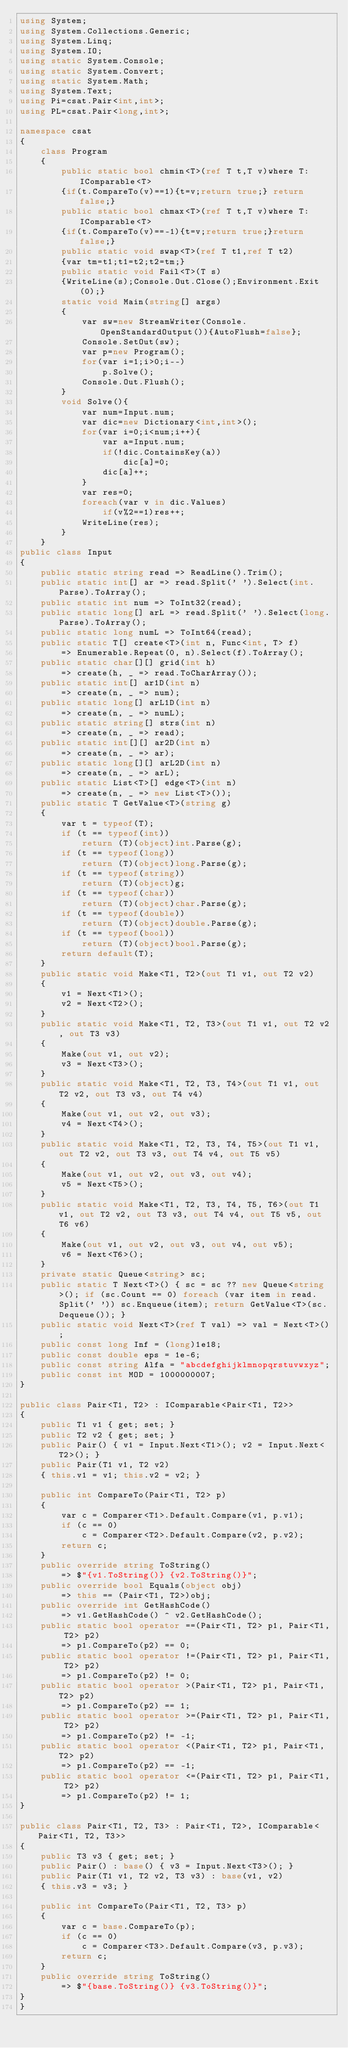<code> <loc_0><loc_0><loc_500><loc_500><_C#_>using System;
using System.Collections.Generic;
using System.Linq;
using System.IO;
using static System.Console;
using static System.Convert;
using static System.Math;
using System.Text;
using Pi=csat.Pair<int,int>;
using PL=csat.Pair<long,int>;

namespace csat
{
    class Program
    {
        public static bool chmin<T>(ref T t,T v)where T:IComparable<T>
        {if(t.CompareTo(v)==1){t=v;return true;} return false;}
        public static bool chmax<T>(ref T t,T v)where T:IComparable<T>
        {if(t.CompareTo(v)==-1){t=v;return true;}return false;}
        public static void swap<T>(ref T t1,ref T t2)
        {var tm=t1;t1=t2;t2=tm;}
        public static void Fail<T>(T s)
        {WriteLine(s);Console.Out.Close();Environment.Exit(0);}
        static void Main(string[] args)
        {
            var sw=new StreamWriter(Console.OpenStandardOutput()){AutoFlush=false};
            Console.SetOut(sw);
            var p=new Program();
            for(var i=1;i>0;i--)
                p.Solve();
            Console.Out.Flush();
        }
        void Solve(){
            var num=Input.num;
            var dic=new Dictionary<int,int>();
            for(var i=0;i<num;i++){
                var a=Input.num;
                if(!dic.ContainsKey(a))
                    dic[a]=0;
                dic[a]++;
            }
            var res=0;
            foreach(var v in dic.Values)
                if(v%2==1)res++;
            WriteLine(res);
        }
    }
public class Input
{
    public static string read => ReadLine().Trim();
    public static int[] ar => read.Split(' ').Select(int.Parse).ToArray();
    public static int num => ToInt32(read);
    public static long[] arL => read.Split(' ').Select(long.Parse).ToArray();
    public static long numL => ToInt64(read);
    public static T[] create<T>(int n, Func<int, T> f)
        => Enumerable.Repeat(0, n).Select(f).ToArray();
    public static char[][] grid(int h)
        => create(h, _ => read.ToCharArray());
    public static int[] ar1D(int n)
        => create(n, _ => num);
    public static long[] arL1D(int n)
        => create(n, _ => numL);
    public static string[] strs(int n)
        => create(n, _ => read);
    public static int[][] ar2D(int n)
        => create(n, _ => ar);
    public static long[][] arL2D(int n)
        => create(n, _ => arL);
    public static List<T>[] edge<T>(int n)
        => create(n, _ => new List<T>());
    public static T GetValue<T>(string g)
    {
        var t = typeof(T);
        if (t == typeof(int))
            return (T)(object)int.Parse(g);
        if (t == typeof(long))
            return (T)(object)long.Parse(g);
        if (t == typeof(string))
            return (T)(object)g;
        if (t == typeof(char))
            return (T)(object)char.Parse(g);
        if (t == typeof(double))
            return (T)(object)double.Parse(g);
        if (t == typeof(bool))
            return (T)(object)bool.Parse(g);
        return default(T);
    }
    public static void Make<T1, T2>(out T1 v1, out T2 v2)
    {
        v1 = Next<T1>();
        v2 = Next<T2>();
    }
    public static void Make<T1, T2, T3>(out T1 v1, out T2 v2, out T3 v3)
    {
        Make(out v1, out v2);
        v3 = Next<T3>();
    }
    public static void Make<T1, T2, T3, T4>(out T1 v1, out T2 v2, out T3 v3, out T4 v4)
    {
        Make(out v1, out v2, out v3);
        v4 = Next<T4>();
    }
    public static void Make<T1, T2, T3, T4, T5>(out T1 v1, out T2 v2, out T3 v3, out T4 v4, out T5 v5)
    {
        Make(out v1, out v2, out v3, out v4);
        v5 = Next<T5>();
    }
    public static void Make<T1, T2, T3, T4, T5, T6>(out T1 v1, out T2 v2, out T3 v3, out T4 v4, out T5 v5, out T6 v6)
    {
        Make(out v1, out v2, out v3, out v4, out v5);
        v6 = Next<T6>();
    }
    private static Queue<string> sc;
    public static T Next<T>() { sc = sc ?? new Queue<string>(); if (sc.Count == 0) foreach (var item in read.Split(' ')) sc.Enqueue(item); return GetValue<T>(sc.Dequeue()); }
    public static void Next<T>(ref T val) => val = Next<T>();
    public const long Inf = (long)1e18;
    public const double eps = 1e-6;
    public const string Alfa = "abcdefghijklmnopqrstuvwxyz";
    public const int MOD = 1000000007;
}
 
public class Pair<T1, T2> : IComparable<Pair<T1, T2>>
{
    public T1 v1 { get; set; }
    public T2 v2 { get; set; }
    public Pair() { v1 = Input.Next<T1>(); v2 = Input.Next<T2>(); }
    public Pair(T1 v1, T2 v2)
    { this.v1 = v1; this.v2 = v2; }
 
    public int CompareTo(Pair<T1, T2> p)
    {
        var c = Comparer<T1>.Default.Compare(v1, p.v1);
        if (c == 0)
            c = Comparer<T2>.Default.Compare(v2, p.v2);
        return c;
    }
    public override string ToString()
        => $"{v1.ToString()} {v2.ToString()}";
    public override bool Equals(object obj)
        => this == (Pair<T1, T2>)obj;
    public override int GetHashCode()
        => v1.GetHashCode() ^ v2.GetHashCode();
    public static bool operator ==(Pair<T1, T2> p1, Pair<T1, T2> p2)
        => p1.CompareTo(p2) == 0;
    public static bool operator !=(Pair<T1, T2> p1, Pair<T1, T2> p2)
        => p1.CompareTo(p2) != 0;
    public static bool operator >(Pair<T1, T2> p1, Pair<T1, T2> p2)
        => p1.CompareTo(p2) == 1;
    public static bool operator >=(Pair<T1, T2> p1, Pair<T1, T2> p2)
        => p1.CompareTo(p2) != -1;
    public static bool operator <(Pair<T1, T2> p1, Pair<T1, T2> p2)
        => p1.CompareTo(p2) == -1;
    public static bool operator <=(Pair<T1, T2> p1, Pair<T1, T2> p2)
        => p1.CompareTo(p2) != 1;
}
 
public class Pair<T1, T2, T3> : Pair<T1, T2>, IComparable<Pair<T1, T2, T3>>
{
    public T3 v3 { get; set; }
    public Pair() : base() { v3 = Input.Next<T3>(); }
    public Pair(T1 v1, T2 v2, T3 v3) : base(v1, v2)
    { this.v3 = v3; }
 
    public int CompareTo(Pair<T1, T2, T3> p)
    {
        var c = base.CompareTo(p);
        if (c == 0)
            c = Comparer<T3>.Default.Compare(v3, p.v3);
        return c;
    }
    public override string ToString()
        => $"{base.ToString()} {v3.ToString()}";
}
}
</code> 